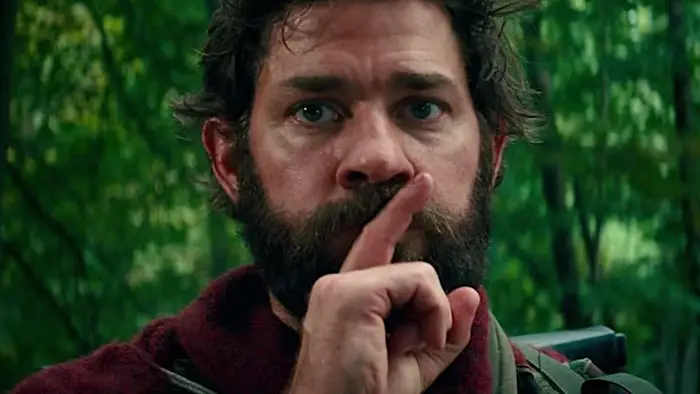What is the significance of the silent gesture in this scene? The silent gesture, with the finger pressed to the lips, is a crucial signal in this scene, likely indicating the necessity for extreme quietness to avoid detection. Given the serious expression and forest backdrop, it suggests that the character might be evading a threat that is highly sensitive to noise, adding a layer of suspense and urgency to the scene. What could be lurking in the forest that necessitates such silence? The dense and shadowy forest background implies an environment where dangerous creatures could be hiding. These creatures might have heightened auditory senses, making any sound a potential signal for attack. The character's serious expression and silence gesture add to the tension, hinting at the stakes involved in making any noise. The forest could be teeming with unknown entities, adding an element of mystery and danger to the scene. What might be the backstory of this character? This character appears to be someone experienced in survival, given his serious demeanor and the context of the scene. He might be a father or leader, responsible for protecting others in a post-apocalyptic world where silence is crucial for survival. His rugged appearance and practical clothing suggest he has been enduring harsh conditions for a prolonged period. The red jacket might symbolize a personal connection to someone he is protecting or mourning. Imagine there's a mythical creature in the forest. What would it look like? In the depths of this shadowy forest could lurk a mythical creature known as the Silence Stalker. This creature is covered in chameleon-like skin that blends seamlessly with the surroundings, making it nearly invisible. It has elongated limbs for swift and silent movement, with ears that can pinpoint the faintest of sounds from miles away. Its eyes are luminescent, glowing faintly in the dark, and it communicates through low-frequency vibrations. The Silence Stalker hunts anything that disrupts the nocturnal peace, making silence a matter of life and death for anyone traversing its territory. 